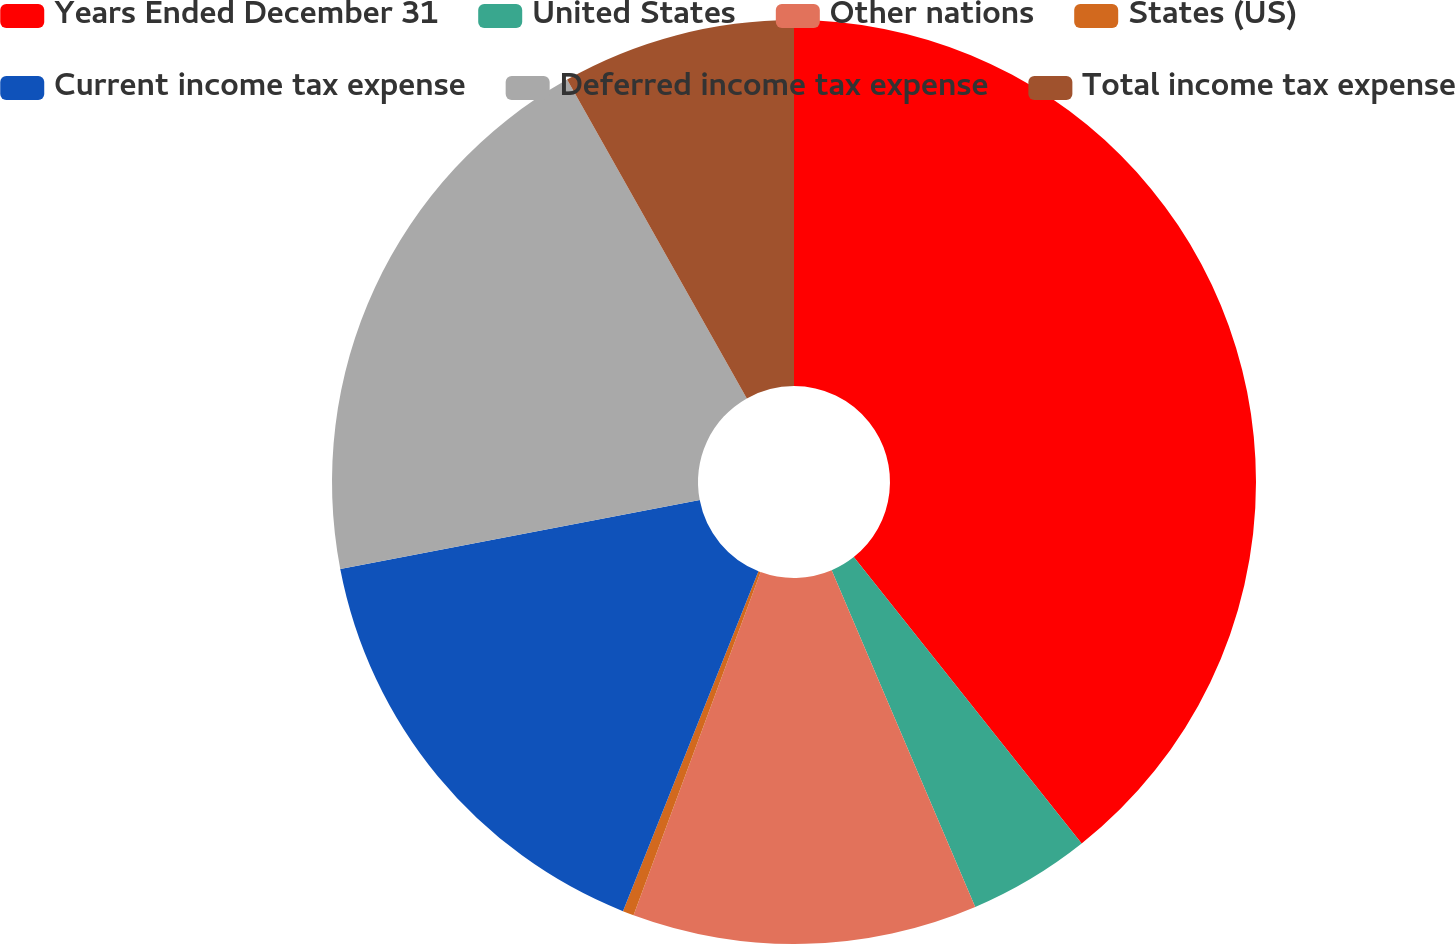Convert chart to OTSL. <chart><loc_0><loc_0><loc_500><loc_500><pie_chart><fcel>Years Ended December 31<fcel>United States<fcel>Other nations<fcel>States (US)<fcel>Current income tax expense<fcel>Deferred income tax expense<fcel>Total income tax expense<nl><fcel>39.3%<fcel>4.28%<fcel>12.06%<fcel>0.39%<fcel>15.95%<fcel>19.84%<fcel>8.17%<nl></chart> 